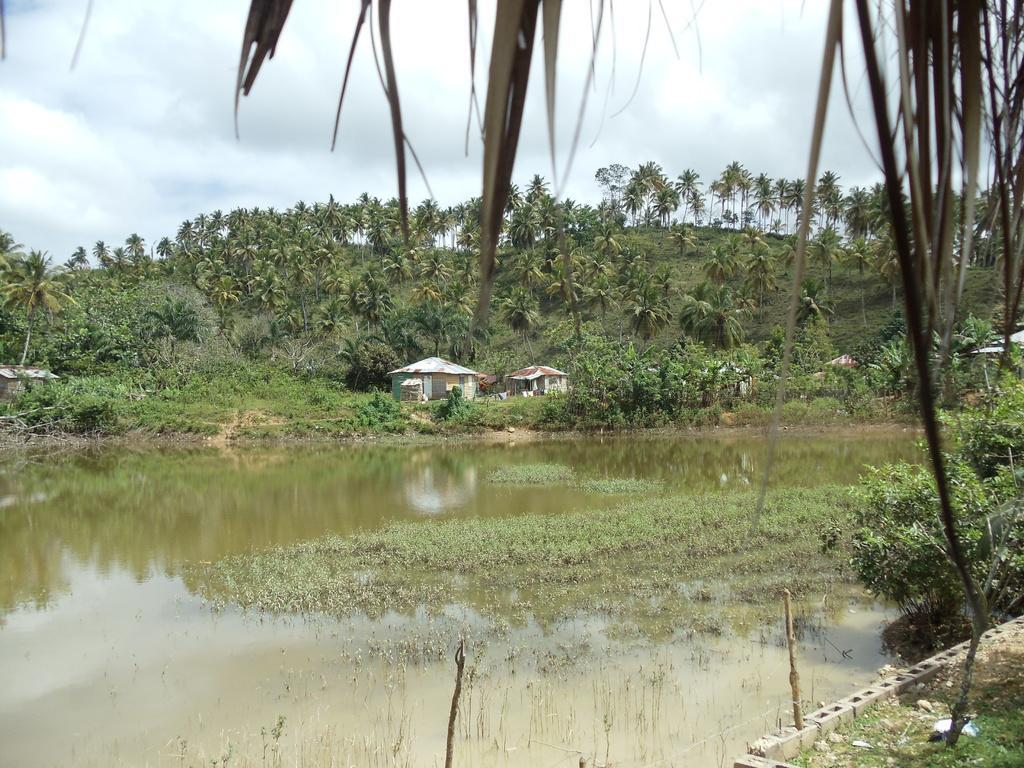Could you give a brief overview of what you see in this image? In this image we can see a pond. Behind the pond grassy land, trees, hut and cloudy sky is present. 